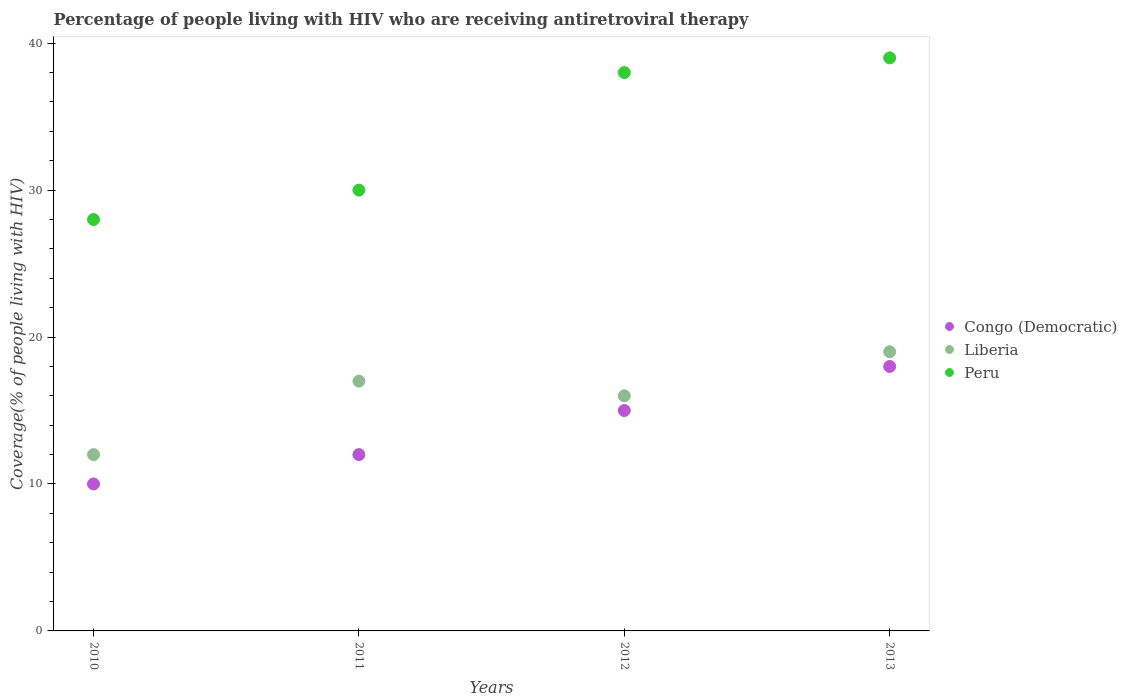What is the percentage of the HIV infected people who are receiving antiretroviral therapy in Congo (Democratic) in 2012?
Provide a succinct answer. 15. Across all years, what is the maximum percentage of the HIV infected people who are receiving antiretroviral therapy in Congo (Democratic)?
Offer a very short reply. 18. Across all years, what is the minimum percentage of the HIV infected people who are receiving antiretroviral therapy in Liberia?
Provide a succinct answer. 12. In which year was the percentage of the HIV infected people who are receiving antiretroviral therapy in Peru minimum?
Provide a short and direct response. 2010. What is the total percentage of the HIV infected people who are receiving antiretroviral therapy in Congo (Democratic) in the graph?
Give a very brief answer. 55. What is the difference between the percentage of the HIV infected people who are receiving antiretroviral therapy in Congo (Democratic) in 2012 and that in 2013?
Provide a short and direct response. -3. What is the difference between the percentage of the HIV infected people who are receiving antiretroviral therapy in Liberia in 2010 and the percentage of the HIV infected people who are receiving antiretroviral therapy in Peru in 2012?
Keep it short and to the point. -26. In the year 2010, what is the difference between the percentage of the HIV infected people who are receiving antiretroviral therapy in Liberia and percentage of the HIV infected people who are receiving antiretroviral therapy in Congo (Democratic)?
Provide a short and direct response. 2. In how many years, is the percentage of the HIV infected people who are receiving antiretroviral therapy in Peru greater than 38 %?
Your answer should be compact. 1. What is the ratio of the percentage of the HIV infected people who are receiving antiretroviral therapy in Congo (Democratic) in 2011 to that in 2013?
Provide a short and direct response. 0.67. Is the difference between the percentage of the HIV infected people who are receiving antiretroviral therapy in Liberia in 2010 and 2011 greater than the difference between the percentage of the HIV infected people who are receiving antiretroviral therapy in Congo (Democratic) in 2010 and 2011?
Provide a short and direct response. No. What is the difference between the highest and the lowest percentage of the HIV infected people who are receiving antiretroviral therapy in Congo (Democratic)?
Ensure brevity in your answer.  8. Does the percentage of the HIV infected people who are receiving antiretroviral therapy in Peru monotonically increase over the years?
Provide a succinct answer. Yes. Is the percentage of the HIV infected people who are receiving antiretroviral therapy in Liberia strictly greater than the percentage of the HIV infected people who are receiving antiretroviral therapy in Congo (Democratic) over the years?
Make the answer very short. Yes. Does the graph contain any zero values?
Provide a short and direct response. No. Where does the legend appear in the graph?
Keep it short and to the point. Center right. How many legend labels are there?
Keep it short and to the point. 3. How are the legend labels stacked?
Ensure brevity in your answer.  Vertical. What is the title of the graph?
Ensure brevity in your answer.  Percentage of people living with HIV who are receiving antiretroviral therapy. Does "Bermuda" appear as one of the legend labels in the graph?
Keep it short and to the point. No. What is the label or title of the Y-axis?
Provide a succinct answer. Coverage(% of people living with HIV). What is the Coverage(% of people living with HIV) of Congo (Democratic) in 2010?
Keep it short and to the point. 10. What is the Coverage(% of people living with HIV) in Liberia in 2010?
Offer a terse response. 12. What is the Coverage(% of people living with HIV) in Peru in 2010?
Give a very brief answer. 28. What is the Coverage(% of people living with HIV) of Congo (Democratic) in 2012?
Offer a very short reply. 15. What is the Coverage(% of people living with HIV) in Peru in 2012?
Make the answer very short. 38. Across all years, what is the maximum Coverage(% of people living with HIV) of Liberia?
Offer a terse response. 19. Across all years, what is the maximum Coverage(% of people living with HIV) in Peru?
Provide a short and direct response. 39. Across all years, what is the minimum Coverage(% of people living with HIV) in Congo (Democratic)?
Your response must be concise. 10. Across all years, what is the minimum Coverage(% of people living with HIV) of Liberia?
Your response must be concise. 12. Across all years, what is the minimum Coverage(% of people living with HIV) of Peru?
Your response must be concise. 28. What is the total Coverage(% of people living with HIV) in Congo (Democratic) in the graph?
Provide a succinct answer. 55. What is the total Coverage(% of people living with HIV) in Peru in the graph?
Your response must be concise. 135. What is the difference between the Coverage(% of people living with HIV) of Congo (Democratic) in 2010 and that in 2011?
Your response must be concise. -2. What is the difference between the Coverage(% of people living with HIV) in Peru in 2010 and that in 2011?
Make the answer very short. -2. What is the difference between the Coverage(% of people living with HIV) in Congo (Democratic) in 2010 and that in 2012?
Your response must be concise. -5. What is the difference between the Coverage(% of people living with HIV) of Liberia in 2010 and that in 2012?
Provide a succinct answer. -4. What is the difference between the Coverage(% of people living with HIV) of Peru in 2010 and that in 2013?
Your response must be concise. -11. What is the difference between the Coverage(% of people living with HIV) of Congo (Democratic) in 2011 and that in 2012?
Offer a very short reply. -3. What is the difference between the Coverage(% of people living with HIV) in Liberia in 2011 and that in 2013?
Your answer should be compact. -2. What is the difference between the Coverage(% of people living with HIV) of Liberia in 2012 and that in 2013?
Your answer should be very brief. -3. What is the difference between the Coverage(% of people living with HIV) in Congo (Democratic) in 2010 and the Coverage(% of people living with HIV) in Liberia in 2011?
Provide a succinct answer. -7. What is the difference between the Coverage(% of people living with HIV) of Liberia in 2010 and the Coverage(% of people living with HIV) of Peru in 2012?
Your answer should be compact. -26. What is the difference between the Coverage(% of people living with HIV) in Congo (Democratic) in 2010 and the Coverage(% of people living with HIV) in Peru in 2013?
Make the answer very short. -29. What is the difference between the Coverage(% of people living with HIV) in Congo (Democratic) in 2011 and the Coverage(% of people living with HIV) in Peru in 2012?
Make the answer very short. -26. What is the difference between the Coverage(% of people living with HIV) of Congo (Democratic) in 2012 and the Coverage(% of people living with HIV) of Peru in 2013?
Your response must be concise. -24. What is the difference between the Coverage(% of people living with HIV) in Liberia in 2012 and the Coverage(% of people living with HIV) in Peru in 2013?
Offer a terse response. -23. What is the average Coverage(% of people living with HIV) in Congo (Democratic) per year?
Your answer should be very brief. 13.75. What is the average Coverage(% of people living with HIV) of Liberia per year?
Keep it short and to the point. 16. What is the average Coverage(% of people living with HIV) of Peru per year?
Your response must be concise. 33.75. In the year 2011, what is the difference between the Coverage(% of people living with HIV) in Liberia and Coverage(% of people living with HIV) in Peru?
Ensure brevity in your answer.  -13. In the year 2012, what is the difference between the Coverage(% of people living with HIV) in Congo (Democratic) and Coverage(% of people living with HIV) in Liberia?
Provide a succinct answer. -1. In the year 2012, what is the difference between the Coverage(% of people living with HIV) in Congo (Democratic) and Coverage(% of people living with HIV) in Peru?
Provide a short and direct response. -23. In the year 2012, what is the difference between the Coverage(% of people living with HIV) of Liberia and Coverage(% of people living with HIV) of Peru?
Give a very brief answer. -22. In the year 2013, what is the difference between the Coverage(% of people living with HIV) of Congo (Democratic) and Coverage(% of people living with HIV) of Liberia?
Give a very brief answer. -1. In the year 2013, what is the difference between the Coverage(% of people living with HIV) in Congo (Democratic) and Coverage(% of people living with HIV) in Peru?
Provide a succinct answer. -21. What is the ratio of the Coverage(% of people living with HIV) in Congo (Democratic) in 2010 to that in 2011?
Provide a succinct answer. 0.83. What is the ratio of the Coverage(% of people living with HIV) in Liberia in 2010 to that in 2011?
Your answer should be compact. 0.71. What is the ratio of the Coverage(% of people living with HIV) in Congo (Democratic) in 2010 to that in 2012?
Ensure brevity in your answer.  0.67. What is the ratio of the Coverage(% of people living with HIV) in Liberia in 2010 to that in 2012?
Provide a short and direct response. 0.75. What is the ratio of the Coverage(% of people living with HIV) of Peru in 2010 to that in 2012?
Make the answer very short. 0.74. What is the ratio of the Coverage(% of people living with HIV) in Congo (Democratic) in 2010 to that in 2013?
Your response must be concise. 0.56. What is the ratio of the Coverage(% of people living with HIV) of Liberia in 2010 to that in 2013?
Make the answer very short. 0.63. What is the ratio of the Coverage(% of people living with HIV) in Peru in 2010 to that in 2013?
Keep it short and to the point. 0.72. What is the ratio of the Coverage(% of people living with HIV) of Peru in 2011 to that in 2012?
Offer a terse response. 0.79. What is the ratio of the Coverage(% of people living with HIV) of Liberia in 2011 to that in 2013?
Give a very brief answer. 0.89. What is the ratio of the Coverage(% of people living with HIV) of Peru in 2011 to that in 2013?
Offer a terse response. 0.77. What is the ratio of the Coverage(% of people living with HIV) in Congo (Democratic) in 2012 to that in 2013?
Provide a succinct answer. 0.83. What is the ratio of the Coverage(% of people living with HIV) in Liberia in 2012 to that in 2013?
Offer a very short reply. 0.84. What is the ratio of the Coverage(% of people living with HIV) of Peru in 2012 to that in 2013?
Give a very brief answer. 0.97. What is the difference between the highest and the second highest Coverage(% of people living with HIV) of Congo (Democratic)?
Keep it short and to the point. 3. What is the difference between the highest and the second highest Coverage(% of people living with HIV) of Peru?
Provide a succinct answer. 1. What is the difference between the highest and the lowest Coverage(% of people living with HIV) in Congo (Democratic)?
Your answer should be compact. 8. What is the difference between the highest and the lowest Coverage(% of people living with HIV) in Liberia?
Offer a very short reply. 7. What is the difference between the highest and the lowest Coverage(% of people living with HIV) in Peru?
Offer a terse response. 11. 